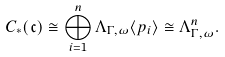Convert formula to latex. <formula><loc_0><loc_0><loc_500><loc_500>C _ { * } ( \mathfrak { c } ) \cong \bigoplus _ { i = 1 } ^ { n } \Lambda _ { \Gamma , \omega } \langle p _ { i } \rangle \cong \Lambda _ { \Gamma , \omega } ^ { n } .</formula> 